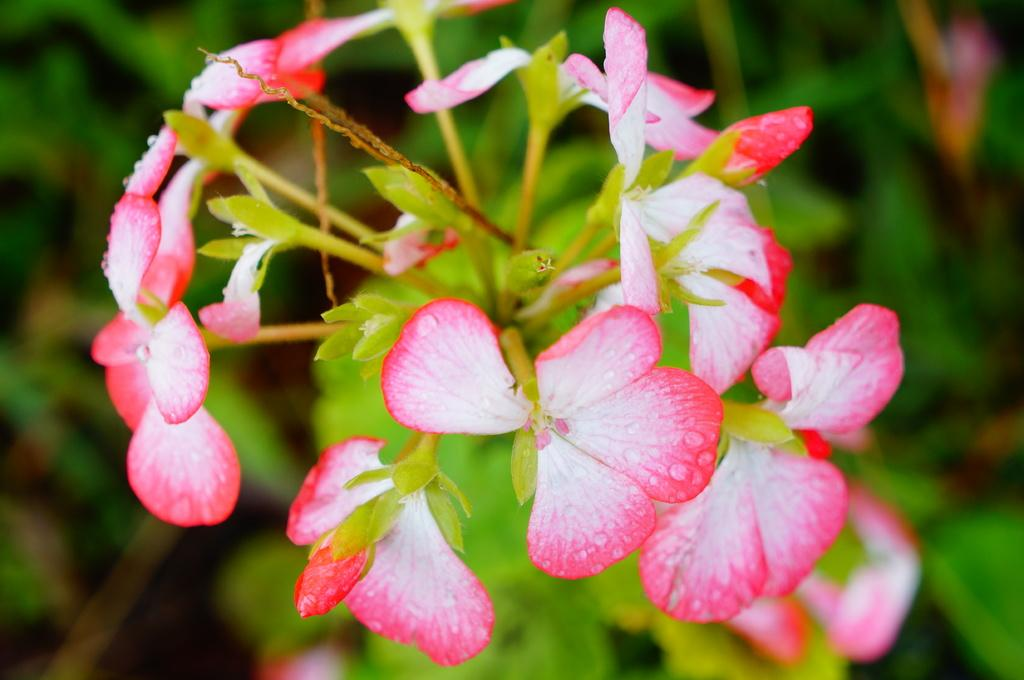What type of plant is visible in the image? There is a plant in the image, and it has flowers and buds. What stage of growth are the flowers in? The flowers are visible on the plant, indicating that they have already bloomed. What can be observed about the background of the image? The background of the image is blurry. What type of plane can be seen flying in the image? There is no plane visible in the image; it only features a plant with flowers and buds. 